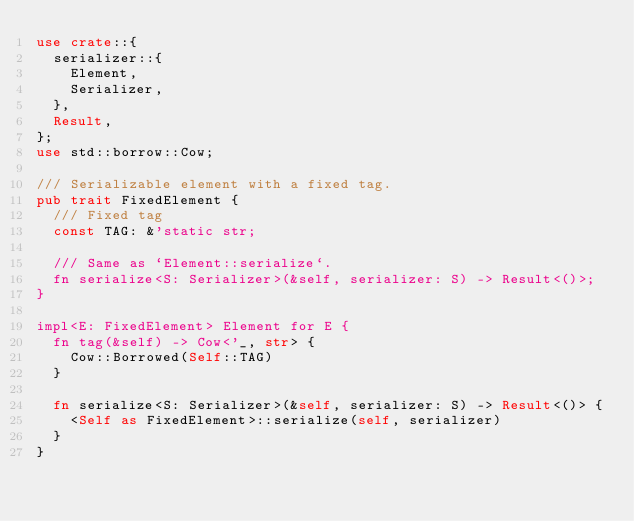<code> <loc_0><loc_0><loc_500><loc_500><_Rust_>use crate::{
	serializer::{
		Element,
		Serializer,
	},
	Result,
};
use std::borrow::Cow;

/// Serializable element with a fixed tag.
pub trait FixedElement {
	/// Fixed tag
	const TAG: &'static str;

	/// Same as `Element::serialize`.
	fn serialize<S: Serializer>(&self, serializer: S) -> Result<()>;
}

impl<E: FixedElement> Element for E {
	fn tag(&self) -> Cow<'_, str> {
		Cow::Borrowed(Self::TAG)
	}

	fn serialize<S: Serializer>(&self, serializer: S) -> Result<()> {
		<Self as FixedElement>::serialize(self, serializer)
	}
}
</code> 